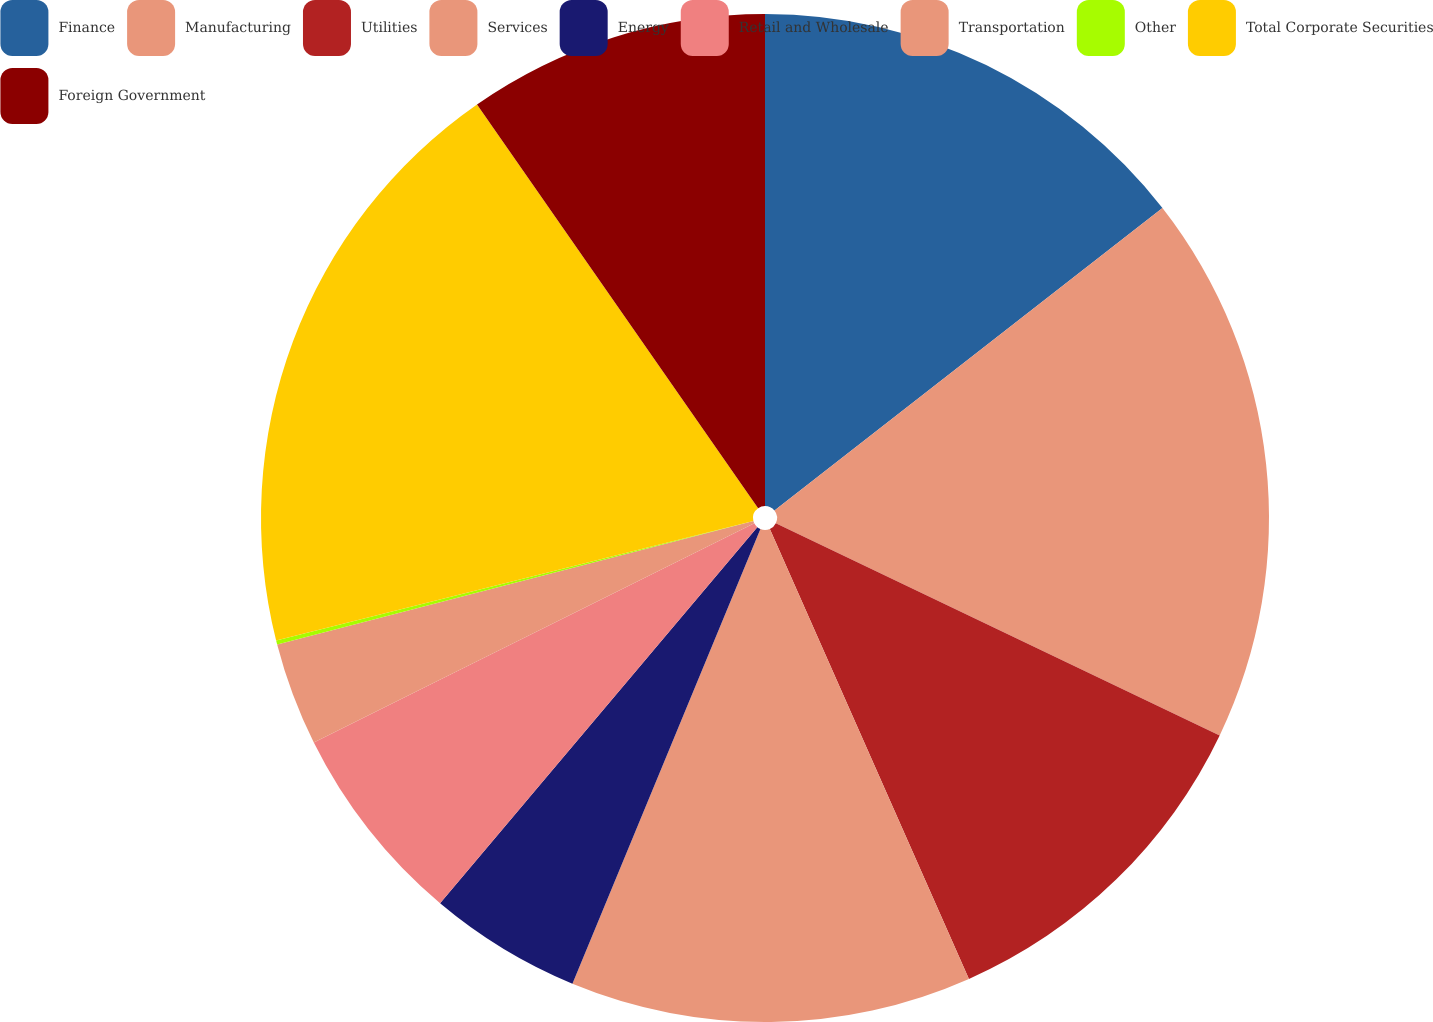Convert chart to OTSL. <chart><loc_0><loc_0><loc_500><loc_500><pie_chart><fcel>Finance<fcel>Manufacturing<fcel>Utilities<fcel>Services<fcel>Energy<fcel>Retail and Wholesale<fcel>Transportation<fcel>Other<fcel>Total Corporate Securities<fcel>Foreign Government<nl><fcel>14.46%<fcel>17.64%<fcel>11.27%<fcel>12.87%<fcel>4.91%<fcel>6.5%<fcel>3.31%<fcel>0.13%<fcel>19.23%<fcel>9.68%<nl></chart> 